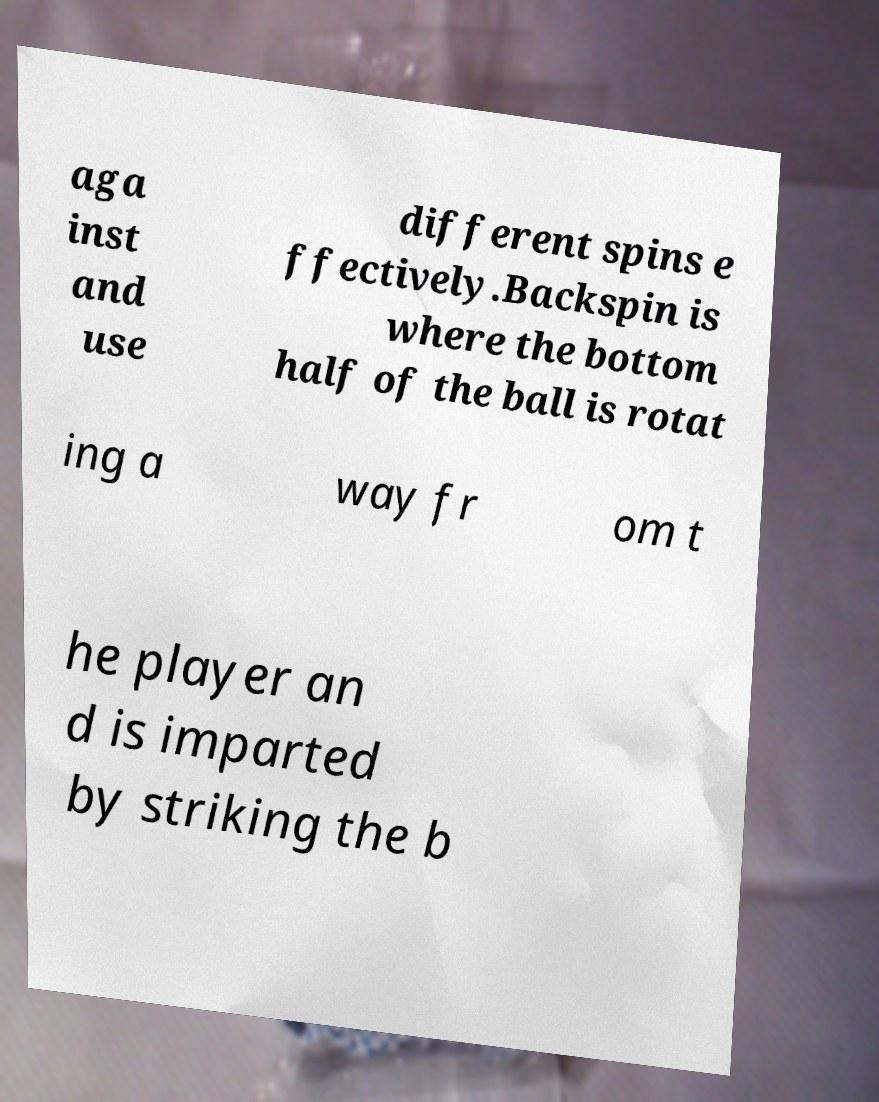I need the written content from this picture converted into text. Can you do that? aga inst and use different spins e ffectively.Backspin is where the bottom half of the ball is rotat ing a way fr om t he player an d is imparted by striking the b 